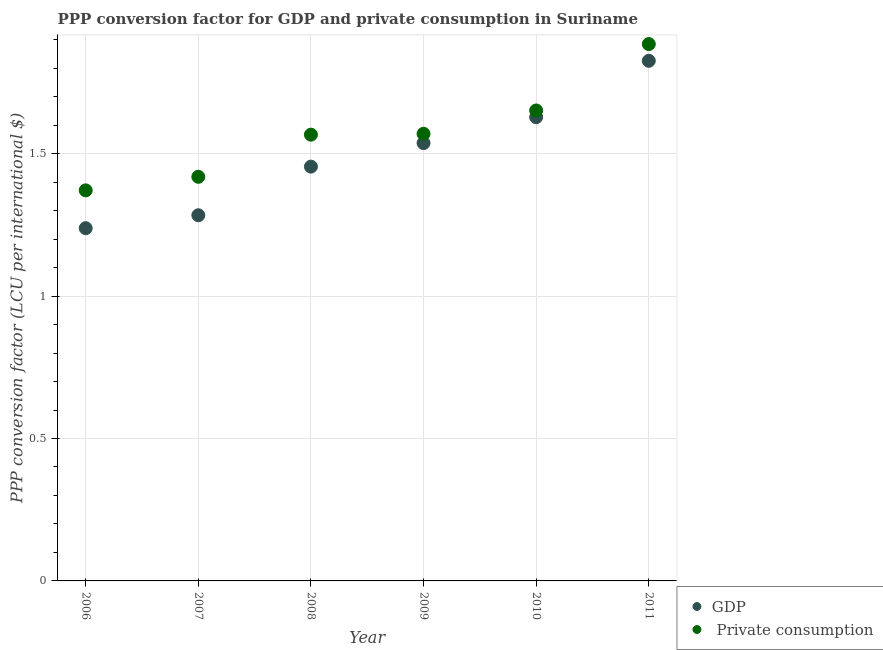How many different coloured dotlines are there?
Your response must be concise. 2. What is the ppp conversion factor for gdp in 2011?
Ensure brevity in your answer.  1.83. Across all years, what is the maximum ppp conversion factor for gdp?
Your answer should be very brief. 1.83. Across all years, what is the minimum ppp conversion factor for private consumption?
Your response must be concise. 1.37. In which year was the ppp conversion factor for gdp maximum?
Your response must be concise. 2011. What is the total ppp conversion factor for private consumption in the graph?
Your response must be concise. 9.46. What is the difference between the ppp conversion factor for gdp in 2006 and that in 2008?
Make the answer very short. -0.22. What is the difference between the ppp conversion factor for private consumption in 2011 and the ppp conversion factor for gdp in 2006?
Keep it short and to the point. 0.65. What is the average ppp conversion factor for gdp per year?
Give a very brief answer. 1.49. In the year 2009, what is the difference between the ppp conversion factor for private consumption and ppp conversion factor for gdp?
Make the answer very short. 0.03. What is the ratio of the ppp conversion factor for private consumption in 2009 to that in 2010?
Offer a terse response. 0.95. What is the difference between the highest and the second highest ppp conversion factor for gdp?
Offer a very short reply. 0.2. What is the difference between the highest and the lowest ppp conversion factor for private consumption?
Offer a terse response. 0.51. In how many years, is the ppp conversion factor for gdp greater than the average ppp conversion factor for gdp taken over all years?
Ensure brevity in your answer.  3. Is the sum of the ppp conversion factor for gdp in 2006 and 2010 greater than the maximum ppp conversion factor for private consumption across all years?
Your answer should be very brief. Yes. Is the ppp conversion factor for private consumption strictly greater than the ppp conversion factor for gdp over the years?
Make the answer very short. Yes. Does the graph contain any zero values?
Keep it short and to the point. No. What is the title of the graph?
Provide a succinct answer. PPP conversion factor for GDP and private consumption in Suriname. Does "Malaria" appear as one of the legend labels in the graph?
Ensure brevity in your answer.  No. What is the label or title of the Y-axis?
Your response must be concise. PPP conversion factor (LCU per international $). What is the PPP conversion factor (LCU per international $) in GDP in 2006?
Provide a succinct answer. 1.24. What is the PPP conversion factor (LCU per international $) of  Private consumption in 2006?
Offer a terse response. 1.37. What is the PPP conversion factor (LCU per international $) in GDP in 2007?
Your answer should be compact. 1.28. What is the PPP conversion factor (LCU per international $) of  Private consumption in 2007?
Offer a very short reply. 1.42. What is the PPP conversion factor (LCU per international $) in GDP in 2008?
Offer a terse response. 1.45. What is the PPP conversion factor (LCU per international $) of  Private consumption in 2008?
Keep it short and to the point. 1.57. What is the PPP conversion factor (LCU per international $) in GDP in 2009?
Make the answer very short. 1.54. What is the PPP conversion factor (LCU per international $) of  Private consumption in 2009?
Offer a very short reply. 1.57. What is the PPP conversion factor (LCU per international $) in GDP in 2010?
Offer a very short reply. 1.63. What is the PPP conversion factor (LCU per international $) in  Private consumption in 2010?
Your response must be concise. 1.65. What is the PPP conversion factor (LCU per international $) in GDP in 2011?
Your response must be concise. 1.83. What is the PPP conversion factor (LCU per international $) in  Private consumption in 2011?
Your response must be concise. 1.88. Across all years, what is the maximum PPP conversion factor (LCU per international $) of GDP?
Offer a very short reply. 1.83. Across all years, what is the maximum PPP conversion factor (LCU per international $) of  Private consumption?
Offer a very short reply. 1.88. Across all years, what is the minimum PPP conversion factor (LCU per international $) in GDP?
Offer a very short reply. 1.24. Across all years, what is the minimum PPP conversion factor (LCU per international $) of  Private consumption?
Offer a terse response. 1.37. What is the total PPP conversion factor (LCU per international $) in GDP in the graph?
Make the answer very short. 8.97. What is the total PPP conversion factor (LCU per international $) of  Private consumption in the graph?
Make the answer very short. 9.46. What is the difference between the PPP conversion factor (LCU per international $) of GDP in 2006 and that in 2007?
Ensure brevity in your answer.  -0.05. What is the difference between the PPP conversion factor (LCU per international $) of  Private consumption in 2006 and that in 2007?
Offer a very short reply. -0.05. What is the difference between the PPP conversion factor (LCU per international $) of GDP in 2006 and that in 2008?
Ensure brevity in your answer.  -0.22. What is the difference between the PPP conversion factor (LCU per international $) of  Private consumption in 2006 and that in 2008?
Provide a succinct answer. -0.2. What is the difference between the PPP conversion factor (LCU per international $) of GDP in 2006 and that in 2009?
Your response must be concise. -0.3. What is the difference between the PPP conversion factor (LCU per international $) of  Private consumption in 2006 and that in 2009?
Your response must be concise. -0.2. What is the difference between the PPP conversion factor (LCU per international $) of GDP in 2006 and that in 2010?
Your response must be concise. -0.39. What is the difference between the PPP conversion factor (LCU per international $) of  Private consumption in 2006 and that in 2010?
Provide a short and direct response. -0.28. What is the difference between the PPP conversion factor (LCU per international $) in GDP in 2006 and that in 2011?
Offer a very short reply. -0.59. What is the difference between the PPP conversion factor (LCU per international $) of  Private consumption in 2006 and that in 2011?
Provide a succinct answer. -0.51. What is the difference between the PPP conversion factor (LCU per international $) of GDP in 2007 and that in 2008?
Provide a succinct answer. -0.17. What is the difference between the PPP conversion factor (LCU per international $) in  Private consumption in 2007 and that in 2008?
Keep it short and to the point. -0.15. What is the difference between the PPP conversion factor (LCU per international $) in GDP in 2007 and that in 2009?
Give a very brief answer. -0.25. What is the difference between the PPP conversion factor (LCU per international $) in  Private consumption in 2007 and that in 2009?
Your answer should be compact. -0.15. What is the difference between the PPP conversion factor (LCU per international $) in GDP in 2007 and that in 2010?
Your answer should be very brief. -0.34. What is the difference between the PPP conversion factor (LCU per international $) in  Private consumption in 2007 and that in 2010?
Make the answer very short. -0.23. What is the difference between the PPP conversion factor (LCU per international $) in GDP in 2007 and that in 2011?
Provide a short and direct response. -0.54. What is the difference between the PPP conversion factor (LCU per international $) in  Private consumption in 2007 and that in 2011?
Provide a succinct answer. -0.47. What is the difference between the PPP conversion factor (LCU per international $) in GDP in 2008 and that in 2009?
Your answer should be very brief. -0.08. What is the difference between the PPP conversion factor (LCU per international $) of  Private consumption in 2008 and that in 2009?
Provide a short and direct response. -0. What is the difference between the PPP conversion factor (LCU per international $) of GDP in 2008 and that in 2010?
Your response must be concise. -0.17. What is the difference between the PPP conversion factor (LCU per international $) in  Private consumption in 2008 and that in 2010?
Your response must be concise. -0.09. What is the difference between the PPP conversion factor (LCU per international $) in GDP in 2008 and that in 2011?
Give a very brief answer. -0.37. What is the difference between the PPP conversion factor (LCU per international $) in  Private consumption in 2008 and that in 2011?
Ensure brevity in your answer.  -0.32. What is the difference between the PPP conversion factor (LCU per international $) of GDP in 2009 and that in 2010?
Give a very brief answer. -0.09. What is the difference between the PPP conversion factor (LCU per international $) in  Private consumption in 2009 and that in 2010?
Ensure brevity in your answer.  -0.08. What is the difference between the PPP conversion factor (LCU per international $) in GDP in 2009 and that in 2011?
Your answer should be compact. -0.29. What is the difference between the PPP conversion factor (LCU per international $) in  Private consumption in 2009 and that in 2011?
Make the answer very short. -0.32. What is the difference between the PPP conversion factor (LCU per international $) in GDP in 2010 and that in 2011?
Provide a short and direct response. -0.2. What is the difference between the PPP conversion factor (LCU per international $) in  Private consumption in 2010 and that in 2011?
Your answer should be very brief. -0.23. What is the difference between the PPP conversion factor (LCU per international $) in GDP in 2006 and the PPP conversion factor (LCU per international $) in  Private consumption in 2007?
Your answer should be compact. -0.18. What is the difference between the PPP conversion factor (LCU per international $) in GDP in 2006 and the PPP conversion factor (LCU per international $) in  Private consumption in 2008?
Your response must be concise. -0.33. What is the difference between the PPP conversion factor (LCU per international $) in GDP in 2006 and the PPP conversion factor (LCU per international $) in  Private consumption in 2009?
Offer a terse response. -0.33. What is the difference between the PPP conversion factor (LCU per international $) in GDP in 2006 and the PPP conversion factor (LCU per international $) in  Private consumption in 2010?
Offer a very short reply. -0.41. What is the difference between the PPP conversion factor (LCU per international $) of GDP in 2006 and the PPP conversion factor (LCU per international $) of  Private consumption in 2011?
Your response must be concise. -0.65. What is the difference between the PPP conversion factor (LCU per international $) in GDP in 2007 and the PPP conversion factor (LCU per international $) in  Private consumption in 2008?
Keep it short and to the point. -0.28. What is the difference between the PPP conversion factor (LCU per international $) in GDP in 2007 and the PPP conversion factor (LCU per international $) in  Private consumption in 2009?
Offer a terse response. -0.29. What is the difference between the PPP conversion factor (LCU per international $) of GDP in 2007 and the PPP conversion factor (LCU per international $) of  Private consumption in 2010?
Offer a terse response. -0.37. What is the difference between the PPP conversion factor (LCU per international $) of GDP in 2007 and the PPP conversion factor (LCU per international $) of  Private consumption in 2011?
Keep it short and to the point. -0.6. What is the difference between the PPP conversion factor (LCU per international $) of GDP in 2008 and the PPP conversion factor (LCU per international $) of  Private consumption in 2009?
Keep it short and to the point. -0.12. What is the difference between the PPP conversion factor (LCU per international $) of GDP in 2008 and the PPP conversion factor (LCU per international $) of  Private consumption in 2010?
Offer a very short reply. -0.2. What is the difference between the PPP conversion factor (LCU per international $) in GDP in 2008 and the PPP conversion factor (LCU per international $) in  Private consumption in 2011?
Keep it short and to the point. -0.43. What is the difference between the PPP conversion factor (LCU per international $) of GDP in 2009 and the PPP conversion factor (LCU per international $) of  Private consumption in 2010?
Keep it short and to the point. -0.11. What is the difference between the PPP conversion factor (LCU per international $) in GDP in 2009 and the PPP conversion factor (LCU per international $) in  Private consumption in 2011?
Ensure brevity in your answer.  -0.35. What is the difference between the PPP conversion factor (LCU per international $) in GDP in 2010 and the PPP conversion factor (LCU per international $) in  Private consumption in 2011?
Your answer should be very brief. -0.26. What is the average PPP conversion factor (LCU per international $) in GDP per year?
Make the answer very short. 1.49. What is the average PPP conversion factor (LCU per international $) in  Private consumption per year?
Your response must be concise. 1.58. In the year 2006, what is the difference between the PPP conversion factor (LCU per international $) in GDP and PPP conversion factor (LCU per international $) in  Private consumption?
Your answer should be compact. -0.13. In the year 2007, what is the difference between the PPP conversion factor (LCU per international $) of GDP and PPP conversion factor (LCU per international $) of  Private consumption?
Your answer should be compact. -0.14. In the year 2008, what is the difference between the PPP conversion factor (LCU per international $) of GDP and PPP conversion factor (LCU per international $) of  Private consumption?
Your response must be concise. -0.11. In the year 2009, what is the difference between the PPP conversion factor (LCU per international $) in GDP and PPP conversion factor (LCU per international $) in  Private consumption?
Your answer should be compact. -0.03. In the year 2010, what is the difference between the PPP conversion factor (LCU per international $) of GDP and PPP conversion factor (LCU per international $) of  Private consumption?
Your answer should be compact. -0.02. In the year 2011, what is the difference between the PPP conversion factor (LCU per international $) in GDP and PPP conversion factor (LCU per international $) in  Private consumption?
Provide a succinct answer. -0.06. What is the ratio of the PPP conversion factor (LCU per international $) of GDP in 2006 to that in 2007?
Keep it short and to the point. 0.96. What is the ratio of the PPP conversion factor (LCU per international $) of  Private consumption in 2006 to that in 2007?
Your answer should be compact. 0.97. What is the ratio of the PPP conversion factor (LCU per international $) in GDP in 2006 to that in 2008?
Keep it short and to the point. 0.85. What is the ratio of the PPP conversion factor (LCU per international $) in  Private consumption in 2006 to that in 2008?
Make the answer very short. 0.88. What is the ratio of the PPP conversion factor (LCU per international $) in GDP in 2006 to that in 2009?
Give a very brief answer. 0.81. What is the ratio of the PPP conversion factor (LCU per international $) in  Private consumption in 2006 to that in 2009?
Provide a short and direct response. 0.87. What is the ratio of the PPP conversion factor (LCU per international $) in GDP in 2006 to that in 2010?
Your answer should be very brief. 0.76. What is the ratio of the PPP conversion factor (LCU per international $) of  Private consumption in 2006 to that in 2010?
Offer a very short reply. 0.83. What is the ratio of the PPP conversion factor (LCU per international $) in GDP in 2006 to that in 2011?
Your response must be concise. 0.68. What is the ratio of the PPP conversion factor (LCU per international $) in  Private consumption in 2006 to that in 2011?
Your answer should be very brief. 0.73. What is the ratio of the PPP conversion factor (LCU per international $) in GDP in 2007 to that in 2008?
Give a very brief answer. 0.88. What is the ratio of the PPP conversion factor (LCU per international $) of  Private consumption in 2007 to that in 2008?
Your response must be concise. 0.91. What is the ratio of the PPP conversion factor (LCU per international $) of GDP in 2007 to that in 2009?
Your answer should be compact. 0.84. What is the ratio of the PPP conversion factor (LCU per international $) of  Private consumption in 2007 to that in 2009?
Your answer should be very brief. 0.9. What is the ratio of the PPP conversion factor (LCU per international $) of GDP in 2007 to that in 2010?
Ensure brevity in your answer.  0.79. What is the ratio of the PPP conversion factor (LCU per international $) in  Private consumption in 2007 to that in 2010?
Provide a short and direct response. 0.86. What is the ratio of the PPP conversion factor (LCU per international $) in GDP in 2007 to that in 2011?
Offer a terse response. 0.7. What is the ratio of the PPP conversion factor (LCU per international $) in  Private consumption in 2007 to that in 2011?
Your response must be concise. 0.75. What is the ratio of the PPP conversion factor (LCU per international $) in GDP in 2008 to that in 2009?
Your response must be concise. 0.95. What is the ratio of the PPP conversion factor (LCU per international $) of  Private consumption in 2008 to that in 2009?
Make the answer very short. 1. What is the ratio of the PPP conversion factor (LCU per international $) in GDP in 2008 to that in 2010?
Give a very brief answer. 0.89. What is the ratio of the PPP conversion factor (LCU per international $) of  Private consumption in 2008 to that in 2010?
Offer a terse response. 0.95. What is the ratio of the PPP conversion factor (LCU per international $) in GDP in 2008 to that in 2011?
Give a very brief answer. 0.8. What is the ratio of the PPP conversion factor (LCU per international $) in  Private consumption in 2008 to that in 2011?
Provide a succinct answer. 0.83. What is the ratio of the PPP conversion factor (LCU per international $) of GDP in 2009 to that in 2010?
Ensure brevity in your answer.  0.94. What is the ratio of the PPP conversion factor (LCU per international $) in  Private consumption in 2009 to that in 2010?
Make the answer very short. 0.95. What is the ratio of the PPP conversion factor (LCU per international $) in GDP in 2009 to that in 2011?
Provide a short and direct response. 0.84. What is the ratio of the PPP conversion factor (LCU per international $) in  Private consumption in 2009 to that in 2011?
Ensure brevity in your answer.  0.83. What is the ratio of the PPP conversion factor (LCU per international $) of GDP in 2010 to that in 2011?
Provide a succinct answer. 0.89. What is the ratio of the PPP conversion factor (LCU per international $) in  Private consumption in 2010 to that in 2011?
Provide a succinct answer. 0.88. What is the difference between the highest and the second highest PPP conversion factor (LCU per international $) of GDP?
Keep it short and to the point. 0.2. What is the difference between the highest and the second highest PPP conversion factor (LCU per international $) of  Private consumption?
Keep it short and to the point. 0.23. What is the difference between the highest and the lowest PPP conversion factor (LCU per international $) of GDP?
Keep it short and to the point. 0.59. What is the difference between the highest and the lowest PPP conversion factor (LCU per international $) of  Private consumption?
Your response must be concise. 0.51. 